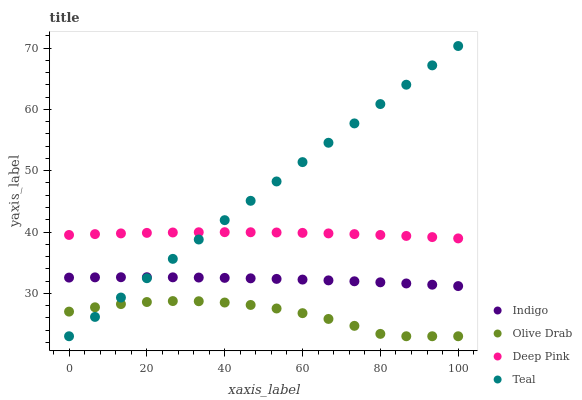Does Olive Drab have the minimum area under the curve?
Answer yes or no. Yes. Does Teal have the maximum area under the curve?
Answer yes or no. Yes. Does Indigo have the minimum area under the curve?
Answer yes or no. No. Does Indigo have the maximum area under the curve?
Answer yes or no. No. Is Teal the smoothest?
Answer yes or no. Yes. Is Olive Drab the roughest?
Answer yes or no. Yes. Is Indigo the smoothest?
Answer yes or no. No. Is Indigo the roughest?
Answer yes or no. No. Does Teal have the lowest value?
Answer yes or no. Yes. Does Indigo have the lowest value?
Answer yes or no. No. Does Teal have the highest value?
Answer yes or no. Yes. Does Indigo have the highest value?
Answer yes or no. No. Is Indigo less than Deep Pink?
Answer yes or no. Yes. Is Indigo greater than Olive Drab?
Answer yes or no. Yes. Does Teal intersect Indigo?
Answer yes or no. Yes. Is Teal less than Indigo?
Answer yes or no. No. Is Teal greater than Indigo?
Answer yes or no. No. Does Indigo intersect Deep Pink?
Answer yes or no. No. 